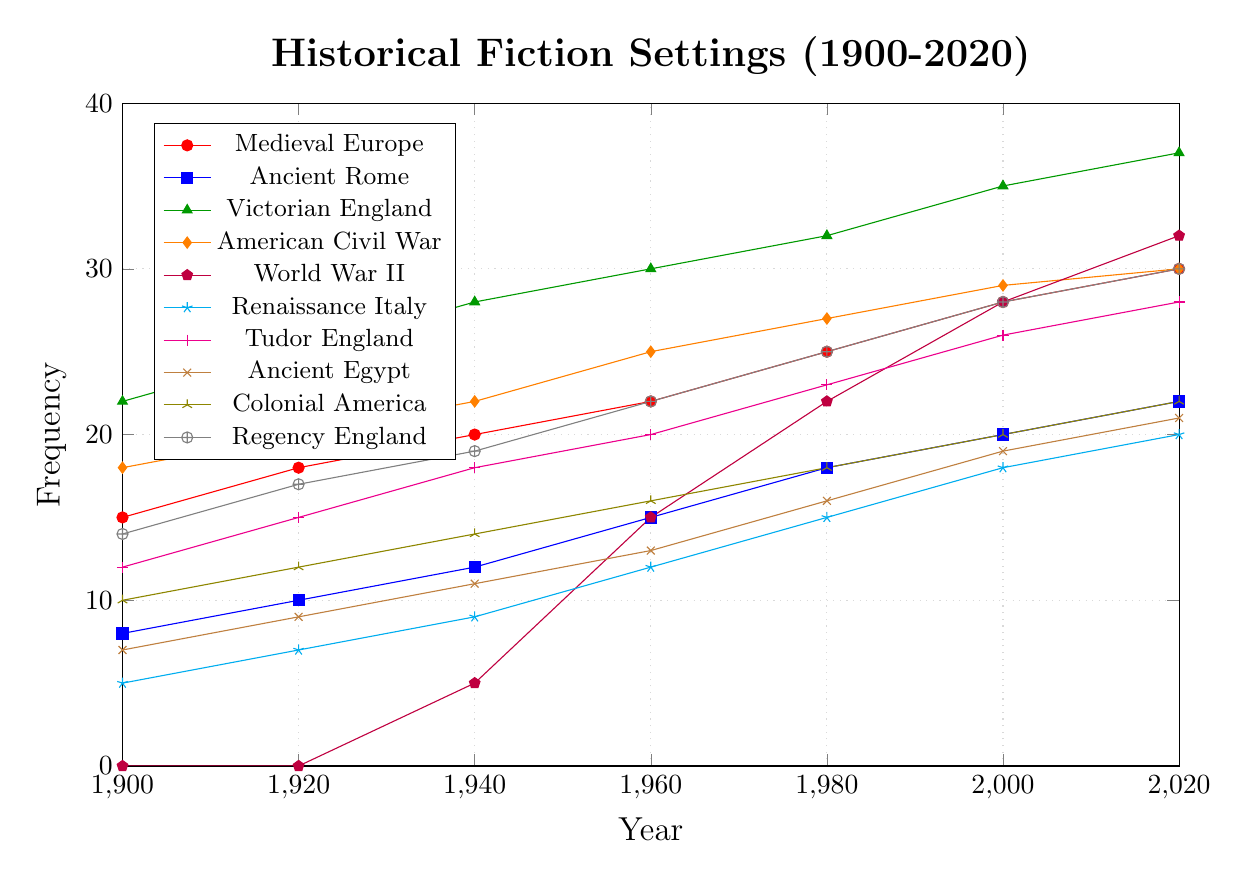Which historical setting had the highest frequency in 2020? To answer this, look at the year 2020 on the x-axis and identify the line with the highest value on the y-axis. The line corresponding to Victorian England with a frequency of 37 is the highest.
Answer: Victorian England Which two historical settings had the same frequency in the year 2000? Compare the y-values for each historical setting at the year 2000. Both Colonial America and Ancient Egypt have a frequency of 20 at this year.
Answer: Colonial America and Ancient Egypt What is the difference in frequency between World War II and Tudor England in 1960? Find the y-values for World War II and Tudor England in 1960. World War II has a frequency of 15, and Tudor England has a frequency of 20. The difference is 20 - 15 = 5.
Answer: 5 Which historical setting showed the largest increase in frequency from 1900 to 2020? Calculate the difference in frequency for each historical setting between 1900 and 2020. Victorian England increased from 22 to 37, a difference of 15, which is the largest.
Answer: Victorian England What is the average frequency of the American Civil War over the given years? Sum the frequencies for the American Civil War across all years then divide by the number of years. The sum is 18 + 20 + 22 + 25 + 27 + 29 + 30 = 171. Divide by 7 (number of years): 171 / 7 ≈ 24.43.
Answer: 24.43 Which historical setting had no publications before 1940? Look at the frequencies before 1940 for each setting. World War II had a frequency of 0 in 1900 and 1920, and it started to appear in 1940.
Answer: World War II Is the frequency of Ancient Rome greater than the frequency of Renaissance Italy in 1920? In 1920, Ancient Rome has a frequency of 10 and Renaissance Italy has a frequency of 7. Since 10 is greater than 7, Ancient Rome is indeed greater.
Answer: Yes How many historical settings had a frequency of 30 or more in 2020? Identify settings with a frequency of 30 or more in the year 2020. The settings are Medieval Europe (30), Victorian England (37), American Civil War (30), and Regency England (30). Hence, there are 4 settings.
Answer: 4 Which historical settings had a frequency of exactly 18 in any year, and in those years, list the corresponding year? Check each historical setting to find the ones that had a frequency of exactly 18 in any year and note the corresponding years. They are:
- Victorian England in 1900
- Tudor England in 1940
- Renaissance Italy in 1980
Answer: Victorian England (1900), Tudor England (1940), Renaissance Italy (1980) What trend do you observe for the frequency of Ancient Egypt from 1900 to 2020? Follow the line for Ancient Egypt from 1900 to 2020. It shows a steady increase from 7 in 1900 to 21 in 2020.
Answer: Steady increase 